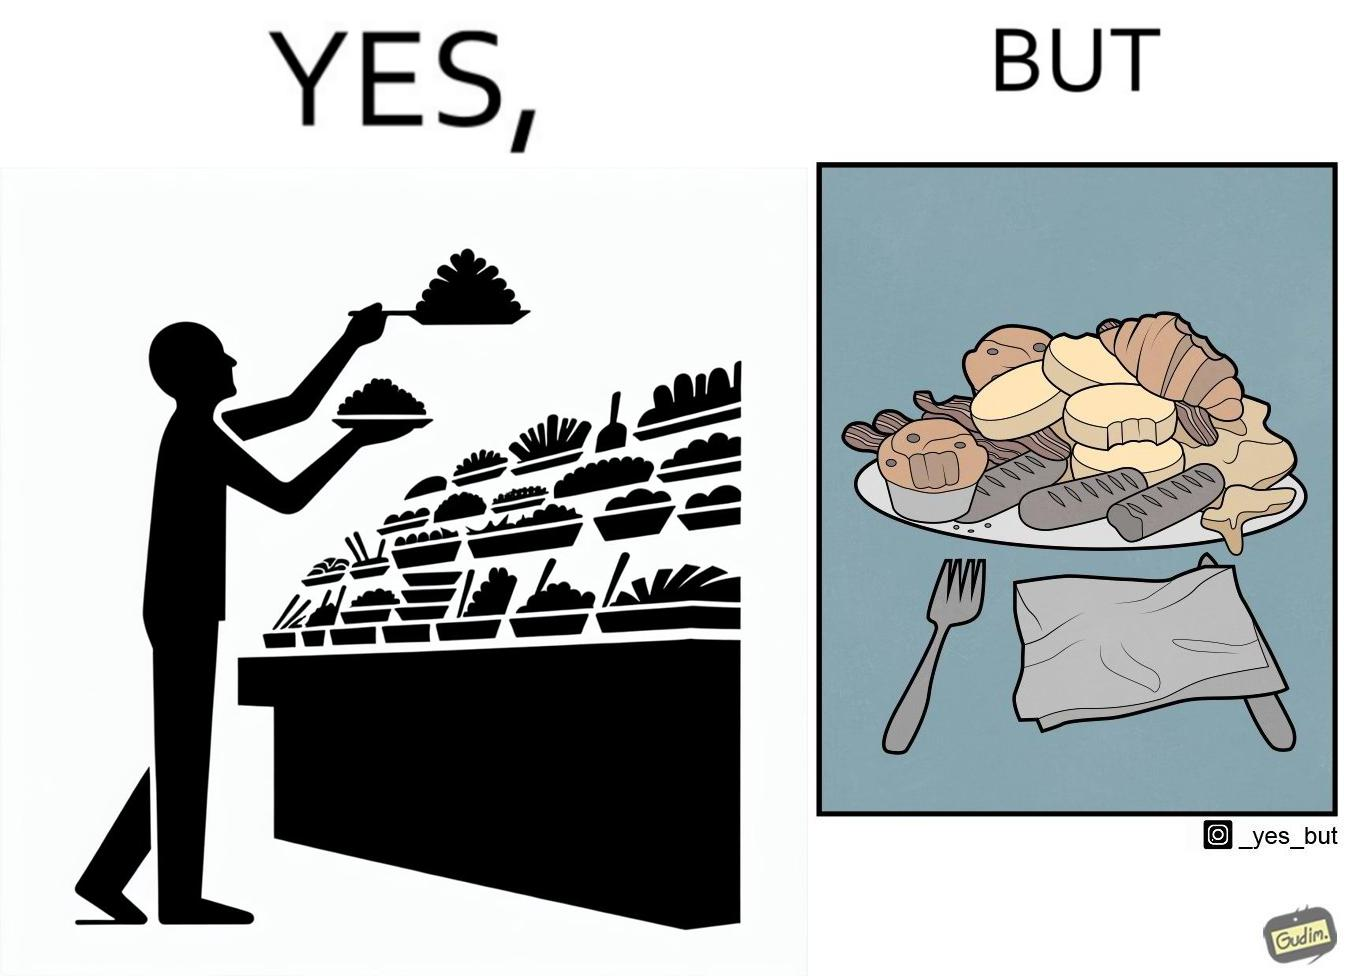What does this image depict? The image is satirical because while the man overfils his plate with differnt food items, he ends up wasting almost all of it by not eating them or by taking just one bite out of them leaving the rest. 